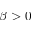<formula> <loc_0><loc_0><loc_500><loc_500>\beta > 0</formula> 